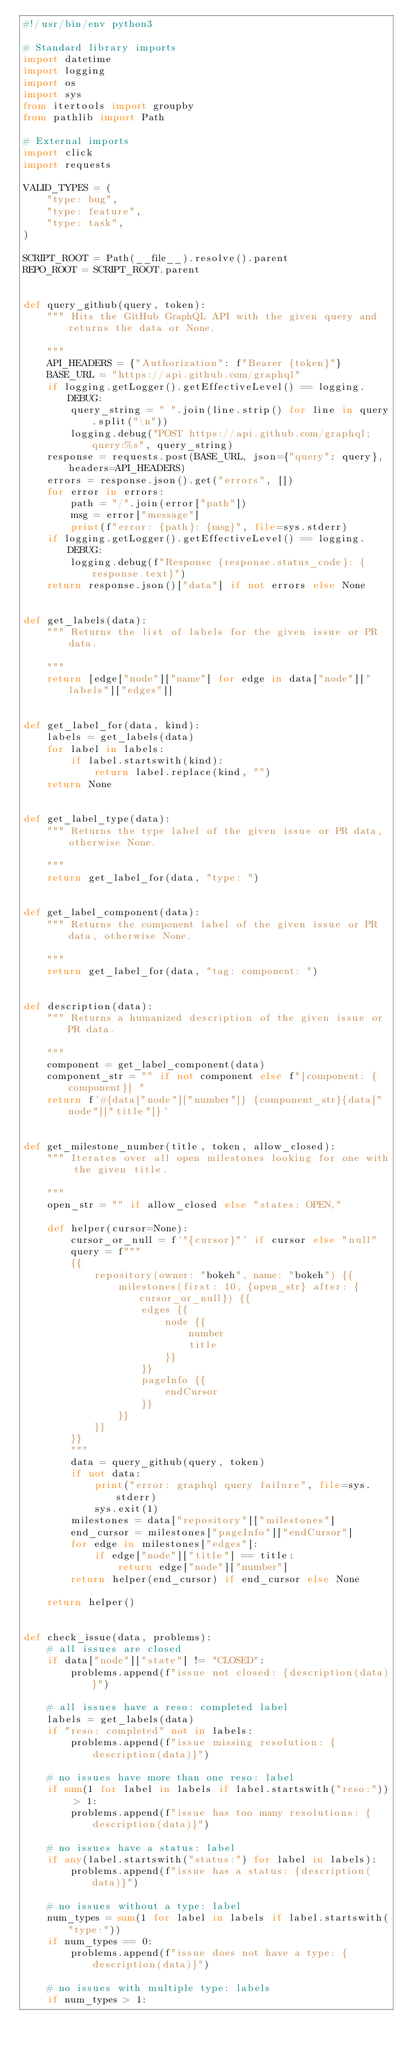Convert code to text. <code><loc_0><loc_0><loc_500><loc_500><_Python_>#!/usr/bin/env python3

# Standard library imports
import datetime
import logging
import os
import sys
from itertools import groupby
from pathlib import Path

# External imports
import click
import requests

VALID_TYPES = (
    "type: bug",
    "type: feature",
    "type: task",
)

SCRIPT_ROOT = Path(__file__).resolve().parent
REPO_ROOT = SCRIPT_ROOT.parent


def query_github(query, token):
    """ Hits the GitHub GraphQL API with the given query and returns the data or None.

    """
    API_HEADERS = {"Authorization": f"Bearer {token}"}
    BASE_URL = "https://api.github.com/graphql"
    if logging.getLogger().getEffectiveLevel() == logging.DEBUG:
        query_string = " ".join(line.strip() for line in query.split("\n"))
        logging.debug("POST https://api.github.com/graphql; query:%s", query_string)
    response = requests.post(BASE_URL, json={"query": query}, headers=API_HEADERS)
    errors = response.json().get("errors", [])
    for error in errors:
        path = "/".join(error["path"])
        msg = error["message"]
        print(f"error: {path}: {msg}", file=sys.stderr)
    if logging.getLogger().getEffectiveLevel() == logging.DEBUG:
        logging.debug(f"Response {response.status_code}: {response.text}")
    return response.json()["data"] if not errors else None


def get_labels(data):
    """ Returns the list of labels for the given issue or PR data.

    """
    return [edge["node"]["name"] for edge in data["node"]["labels"]["edges"]]


def get_label_for(data, kind):
    labels = get_labels(data)
    for label in labels:
        if label.startswith(kind):
            return label.replace(kind, "")
    return None


def get_label_type(data):
    """ Returns the type label of the given issue or PR data, otherwise None.

    """
    return get_label_for(data, "type: ")


def get_label_component(data):
    """ Returns the component label of the given issue or PR data, otherwise None.

    """
    return get_label_for(data, "tag: component: ")


def description(data):
    """ Returns a humanized description of the given issue or PR data.

    """
    component = get_label_component(data)
    component_str = "" if not component else f"[component: {component}] "
    return f'#{data["node"]["number"]} {component_str}{data["node"]["title"]}'


def get_milestone_number(title, token, allow_closed):
    """ Iterates over all open milestones looking for one with the given title.

    """
    open_str = "" if allow_closed else "states: OPEN,"

    def helper(cursor=None):
        cursor_or_null = f'"{cursor}"' if cursor else "null"
        query = f"""
        {{
            repository(owner: "bokeh", name: "bokeh") {{
                milestones(first: 10, {open_str} after: {cursor_or_null}) {{
                    edges {{
                        node {{
                            number
                            title
                        }}
                    }}
                    pageInfo {{
                        endCursor
                    }}
                }}
            }}
        }}
        """
        data = query_github(query, token)
        if not data:
            print("error: graphql query failure", file=sys.stderr)
            sys.exit(1)
        milestones = data["repository"]["milestones"]
        end_cursor = milestones["pageInfo"]["endCursor"]
        for edge in milestones["edges"]:
            if edge["node"]["title"] == title:
                return edge["node"]["number"]
        return helper(end_cursor) if end_cursor else None

    return helper()


def check_issue(data, problems):
    # all issues are closed
    if data["node"]["state"] != "CLOSED":
        problems.append(f"issue not closed: {description(data)}")

    # all issues have a reso: completed label
    labels = get_labels(data)
    if "reso: completed" not in labels:
        problems.append(f"issue missing resolution: {description(data)}")

    # no issues have more than one reso: label
    if sum(1 for label in labels if label.startswith("reso:")) > 1:
        problems.append(f"issue has too many resolutions: {description(data)}")

    # no issues have a status: label
    if any(label.startswith("status:") for label in labels):
        problems.append(f"issue has a status: {description(data)}")

    # no issues without a type: label
    num_types = sum(1 for label in labels if label.startswith("type:"))
    if num_types == 0:
        problems.append(f"issue does not have a type: {description(data)}")

    # no issues with multiple type: labels
    if num_types > 1:</code> 